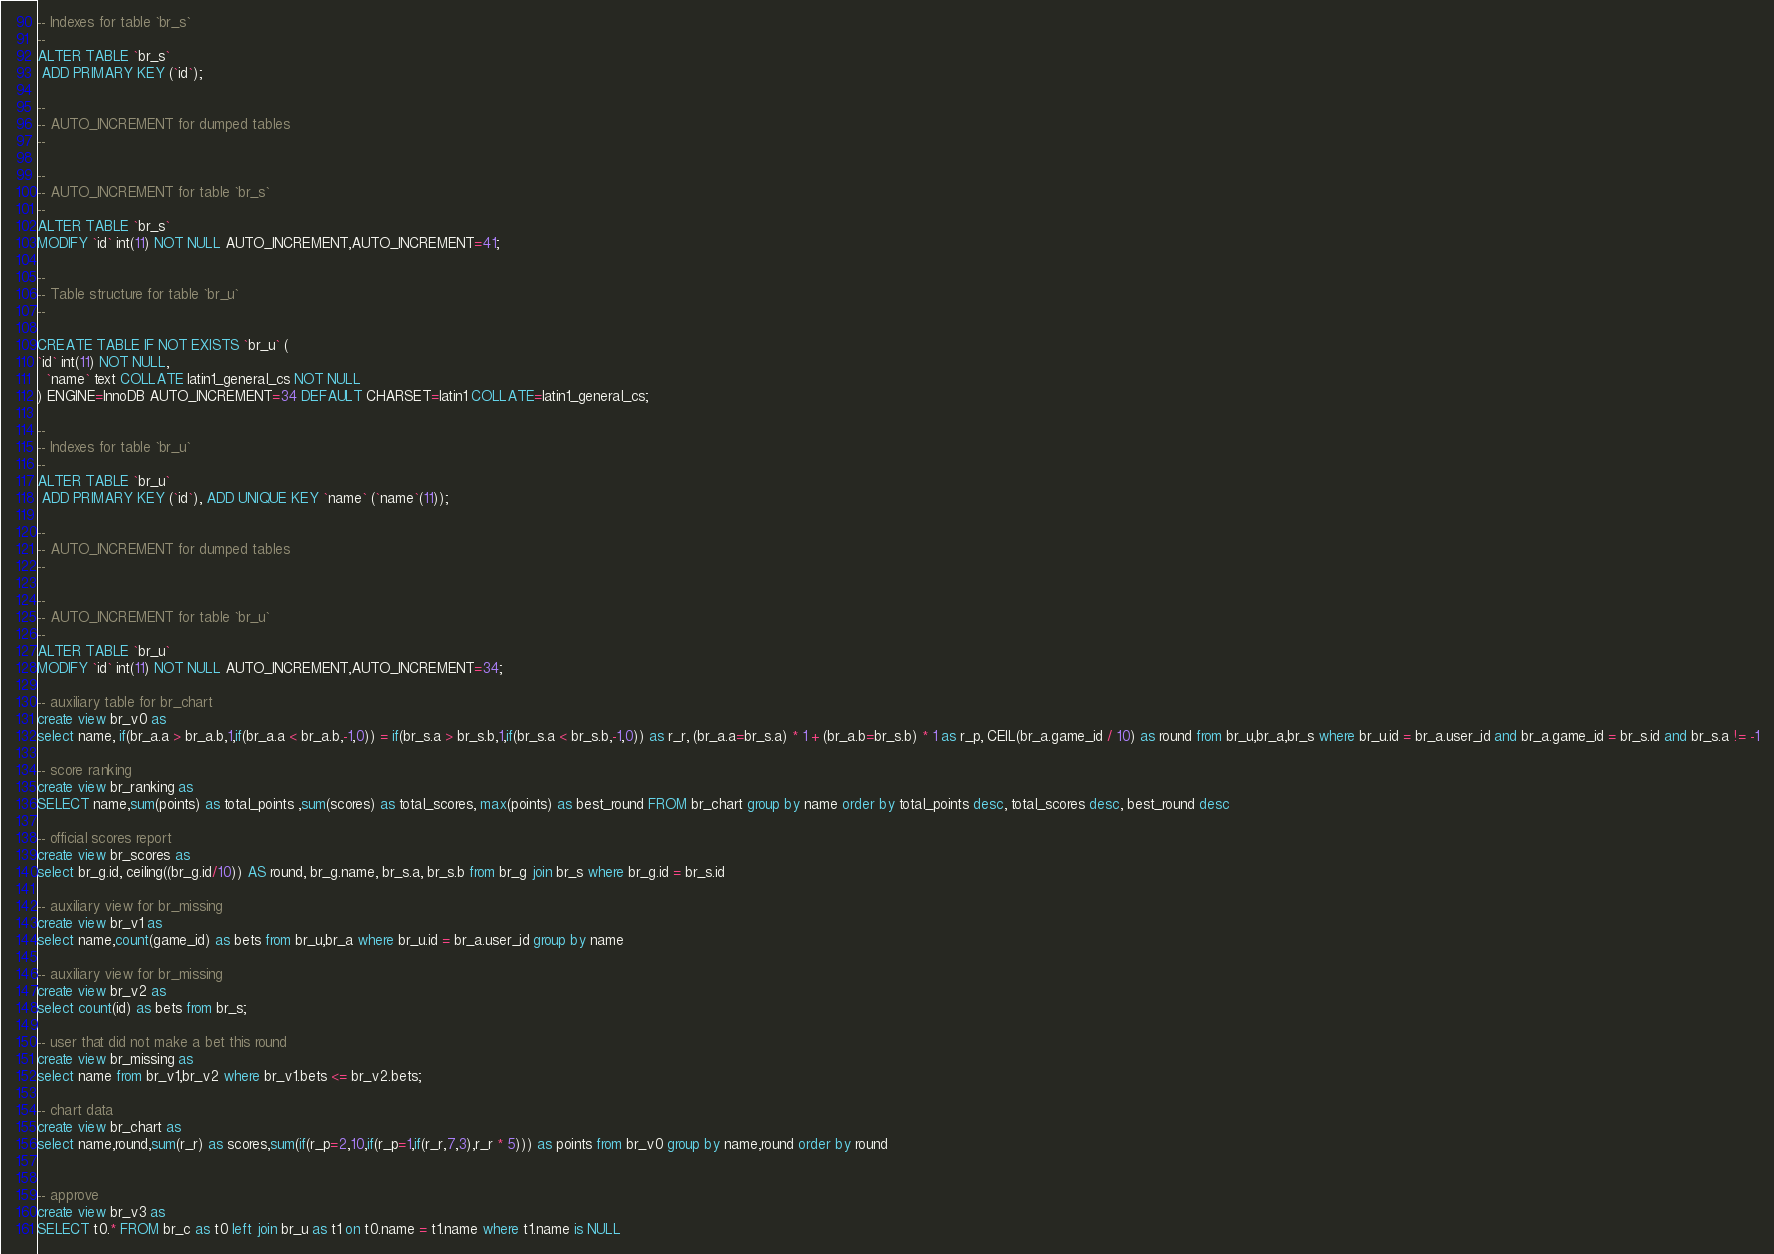<code> <loc_0><loc_0><loc_500><loc_500><_SQL_>-- Indexes for table `br_s`
--
ALTER TABLE `br_s`
 ADD PRIMARY KEY (`id`);

--
-- AUTO_INCREMENT for dumped tables
--

--
-- AUTO_INCREMENT for table `br_s`
--
ALTER TABLE `br_s`
MODIFY `id` int(11) NOT NULL AUTO_INCREMENT,AUTO_INCREMENT=41;

--
-- Table structure for table `br_u`
--

CREATE TABLE IF NOT EXISTS `br_u` (
`id` int(11) NOT NULL,
  `name` text COLLATE latin1_general_cs NOT NULL
) ENGINE=InnoDB AUTO_INCREMENT=34 DEFAULT CHARSET=latin1 COLLATE=latin1_general_cs;

--
-- Indexes for table `br_u`
--
ALTER TABLE `br_u`
 ADD PRIMARY KEY (`id`), ADD UNIQUE KEY `name` (`name`(11));

--
-- AUTO_INCREMENT for dumped tables
--

--
-- AUTO_INCREMENT for table `br_u`
--
ALTER TABLE `br_u`
MODIFY `id` int(11) NOT NULL AUTO_INCREMENT,AUTO_INCREMENT=34;

-- auxiliary table for br_chart
create view br_v0 as 
select name, if(br_a.a > br_a.b,1,if(br_a.a < br_a.b,-1,0)) = if(br_s.a > br_s.b,1,if(br_s.a < br_s.b,-1,0)) as r_r, (br_a.a=br_s.a) * 1 + (br_a.b=br_s.b) * 1 as r_p, CEIL(br_a.game_id / 10) as round from br_u,br_a,br_s where br_u.id = br_a.user_id and br_a.game_id = br_s.id and br_s.a != -1

-- score ranking
create view br_ranking as
SELECT name,sum(points) as total_points ,sum(scores) as total_scores, max(points) as best_round FROM br_chart group by name order by total_points desc, total_scores desc, best_round desc

-- official scores report
create view br_scores as 
select br_g.id, ceiling((br_g.id/10)) AS round, br_g.name, br_s.a, br_s.b from br_g join br_s where br_g.id = br_s.id

-- auxiliary view for br_missing
create view br_v1 as 
select name,count(game_id) as bets from br_u,br_a where br_u.id = br_a.user_id group by name

-- auxiliary view for br_missing
create view br_v2 as 
select count(id) as bets from br_s;

-- user that did not make a bet this round
create view br_missing as 
select name from br_v1,br_v2 where br_v1.bets <= br_v2.bets;

-- chart data
create view br_chart as 
select name,round,sum(r_r) as scores,sum(if(r_p=2,10,if(r_p=1,if(r_r,7,3),r_r * 5))) as points from br_v0 group by name,round order by round


-- approve
create view br_v3 as
SELECT t0.* FROM br_c as t0 left join br_u as t1 on t0.name = t1.name where t1.name is NULL

</code> 